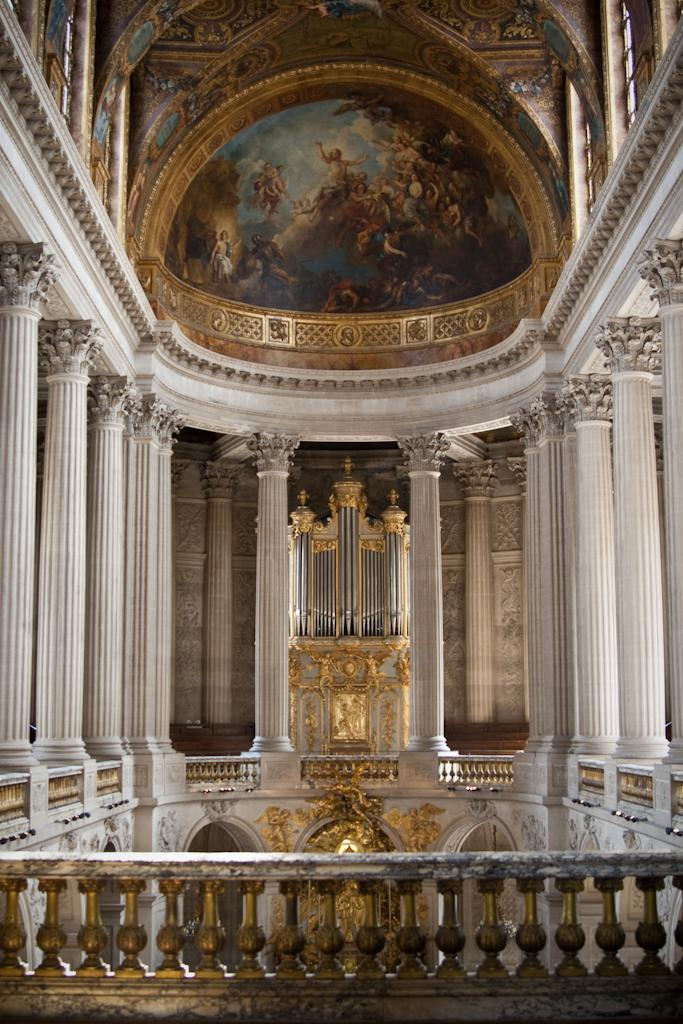What is the main structure visible in the image? There is a building in the image. What is on the roof of the building? There is a painting on the roof of the building. What architectural features can be seen in the building? There are pillars in the building. What type of pear is being served at the feast in the image? There is no feast or pear present in the image; it features a building with a painting on the roof and pillars. 